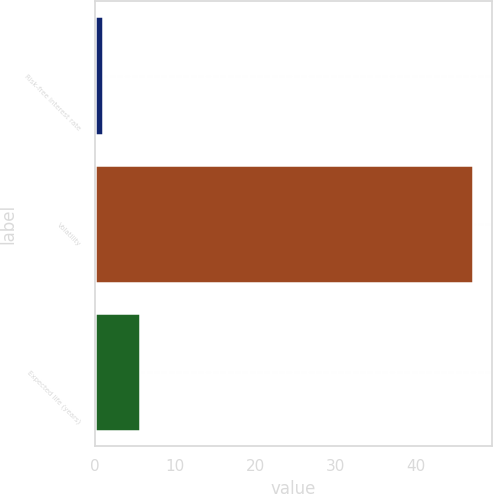Convert chart. <chart><loc_0><loc_0><loc_500><loc_500><bar_chart><fcel>Risk-free interest rate<fcel>Volatility<fcel>Expected life (years)<nl><fcel>1<fcel>47.1<fcel>5.61<nl></chart> 